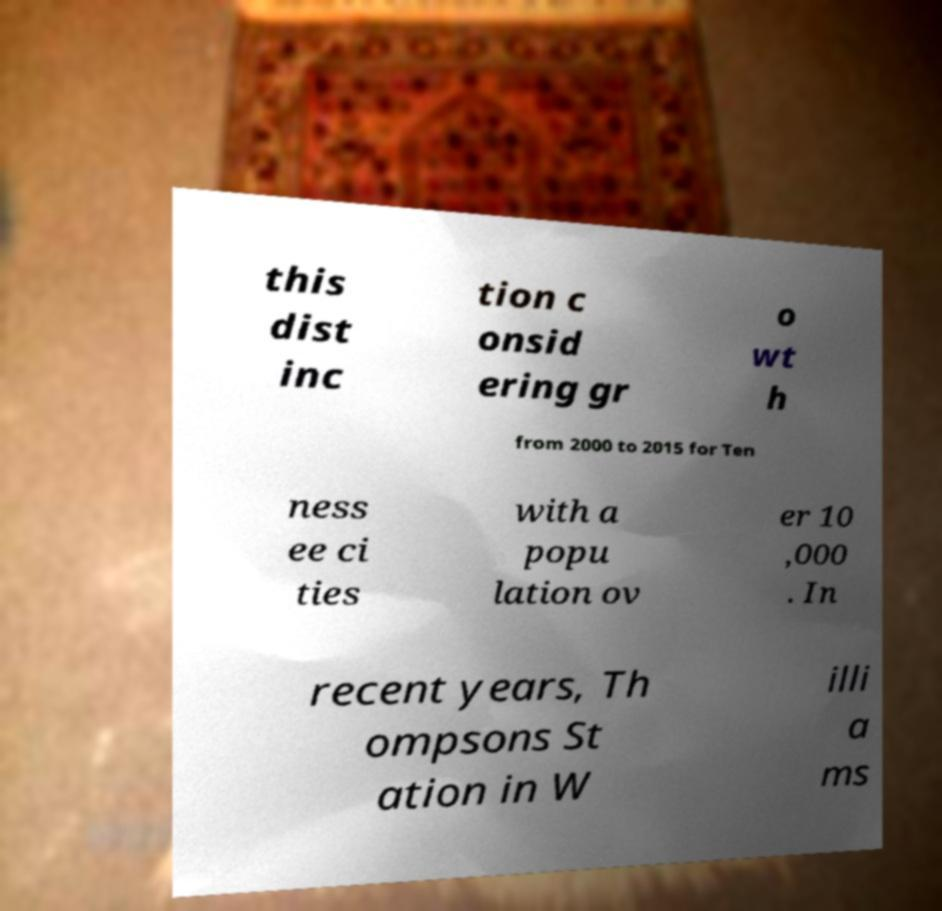For documentation purposes, I need the text within this image transcribed. Could you provide that? this dist inc tion c onsid ering gr o wt h from 2000 to 2015 for Ten ness ee ci ties with a popu lation ov er 10 ,000 . In recent years, Th ompsons St ation in W illi a ms 